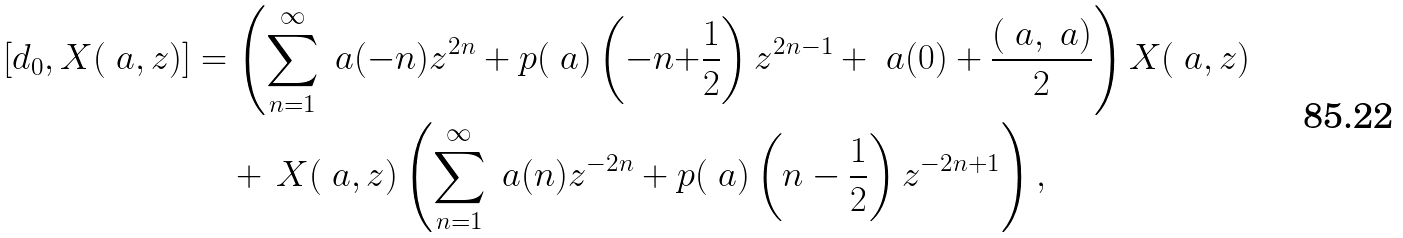Convert formula to latex. <formula><loc_0><loc_0><loc_500><loc_500>\left [ d _ { 0 } , X ( \ a , z ) \right ] & = \left ( \sum _ { n = 1 } ^ { \infty } \ a ( - n ) z ^ { 2 n } + p ( \ a ) \left ( - n { + } \frac { 1 } { 2 } \right ) z ^ { 2 n - 1 } + \ a ( 0 ) + \frac { ( \ a , \ a ) } { 2 } \right ) X ( \ a , z ) \\ & \quad + \, X ( \ a , z ) \left ( \sum _ { n = 1 } ^ { \infty } \ a ( n ) z ^ { - 2 n } + p ( \ a ) \left ( n - \frac { 1 } { 2 } \right ) z ^ { - 2 n + 1 } \right ) ,</formula> 